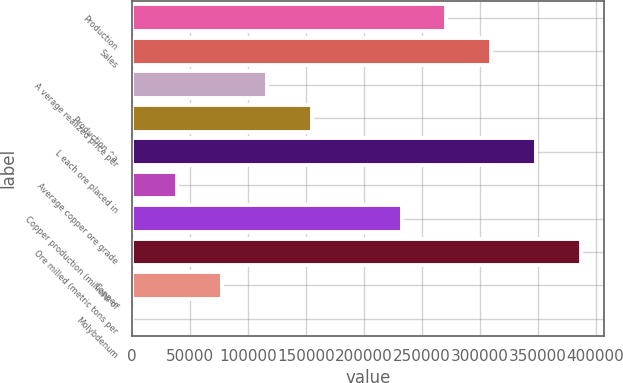Convert chart. <chart><loc_0><loc_0><loc_500><loc_500><bar_chart><fcel>Production<fcel>Sales<fcel>A verage realized price per<fcel>Production ^a<fcel>L each ore placed in<fcel>Average copper ore grade<fcel>Copper production (millions of<fcel>Ore milled (metric tons per<fcel>Copper<fcel>Molybdenum<nl><fcel>271320<fcel>310080<fcel>116280<fcel>155040<fcel>348840<fcel>38760<fcel>232560<fcel>387600<fcel>77520<fcel>0.01<nl></chart> 